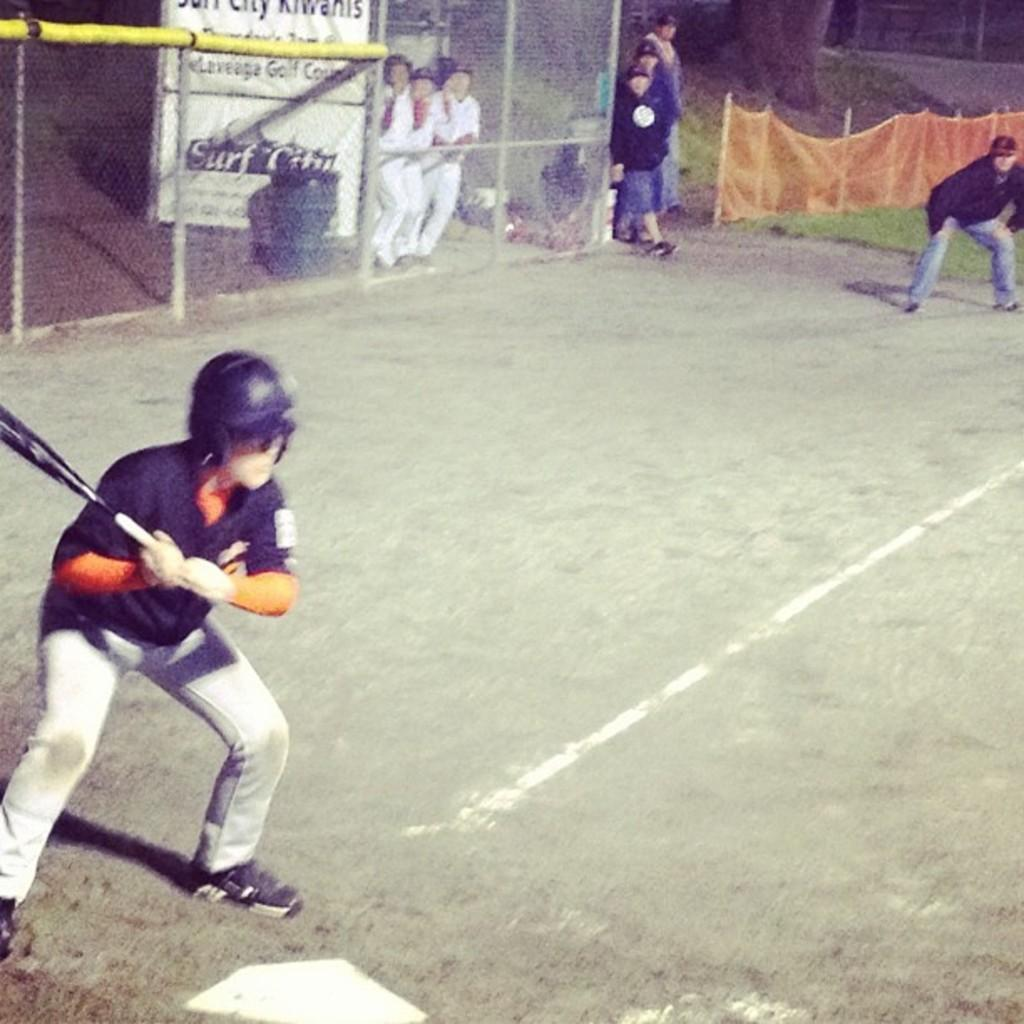<image>
Describe the image concisely. The community baseball team is sponsored by the local Kiwanis. 